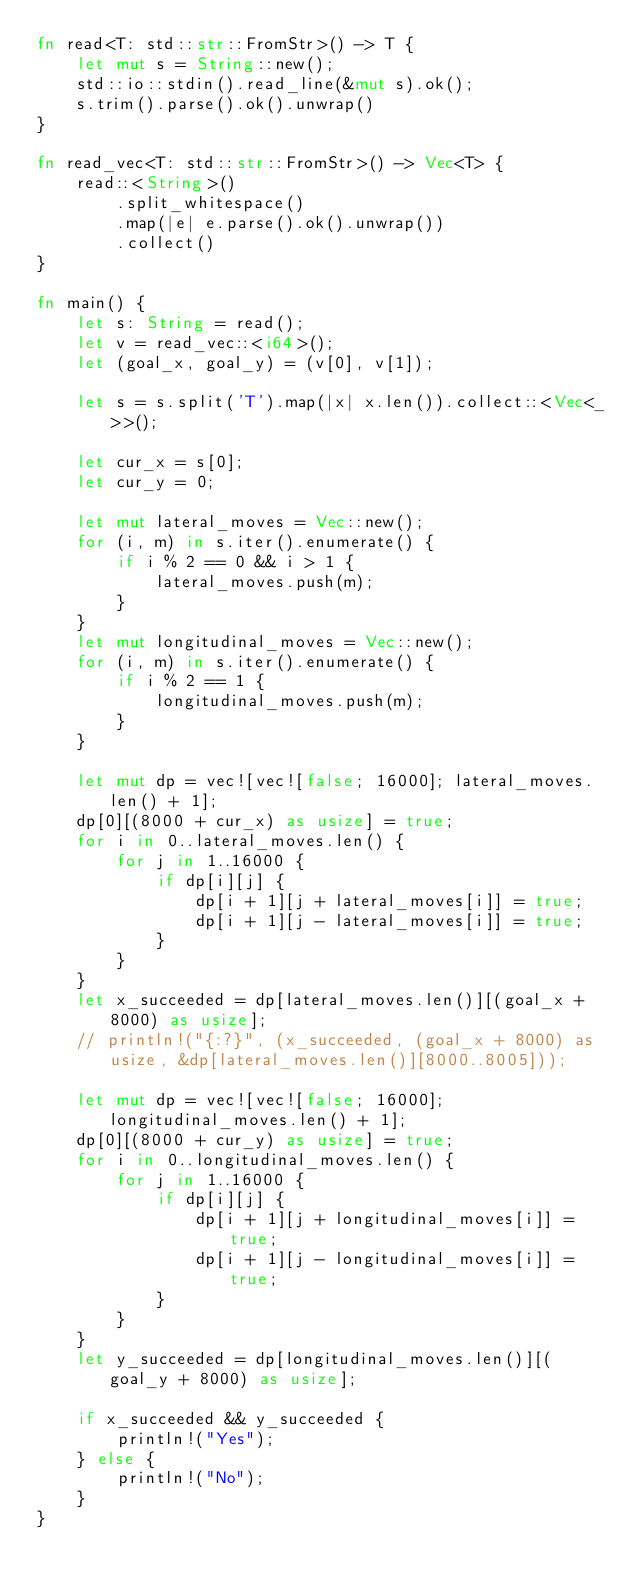Convert code to text. <code><loc_0><loc_0><loc_500><loc_500><_Rust_>fn read<T: std::str::FromStr>() -> T {
    let mut s = String::new();
    std::io::stdin().read_line(&mut s).ok();
    s.trim().parse().ok().unwrap()
}

fn read_vec<T: std::str::FromStr>() -> Vec<T> {
    read::<String>()
        .split_whitespace()
        .map(|e| e.parse().ok().unwrap())
        .collect()
}

fn main() {
    let s: String = read();
    let v = read_vec::<i64>();
    let (goal_x, goal_y) = (v[0], v[1]);

    let s = s.split('T').map(|x| x.len()).collect::<Vec<_>>();

    let cur_x = s[0];
    let cur_y = 0;

    let mut lateral_moves = Vec::new();
    for (i, m) in s.iter().enumerate() {
        if i % 2 == 0 && i > 1 {
            lateral_moves.push(m);
        }
    }
    let mut longitudinal_moves = Vec::new();
    for (i, m) in s.iter().enumerate() {
        if i % 2 == 1 {
            longitudinal_moves.push(m);
        }
    }

    let mut dp = vec![vec![false; 16000]; lateral_moves.len() + 1];
    dp[0][(8000 + cur_x) as usize] = true;
    for i in 0..lateral_moves.len() {
        for j in 1..16000 {
            if dp[i][j] {
                dp[i + 1][j + lateral_moves[i]] = true;
                dp[i + 1][j - lateral_moves[i]] = true;
            }
        }
    }
    let x_succeeded = dp[lateral_moves.len()][(goal_x + 8000) as usize];
    // println!("{:?}", (x_succeeded, (goal_x + 8000) as usize, &dp[lateral_moves.len()][8000..8005]));

    let mut dp = vec![vec![false; 16000]; longitudinal_moves.len() + 1];
    dp[0][(8000 + cur_y) as usize] = true;
    for i in 0..longitudinal_moves.len() {
        for j in 1..16000 {
            if dp[i][j] {
                dp[i + 1][j + longitudinal_moves[i]] = true;
                dp[i + 1][j - longitudinal_moves[i]] = true;
            }
        }
    }
    let y_succeeded = dp[longitudinal_moves.len()][(goal_y + 8000) as usize];

    if x_succeeded && y_succeeded {
        println!("Yes");
    } else {
        println!("No");
    }
}
</code> 